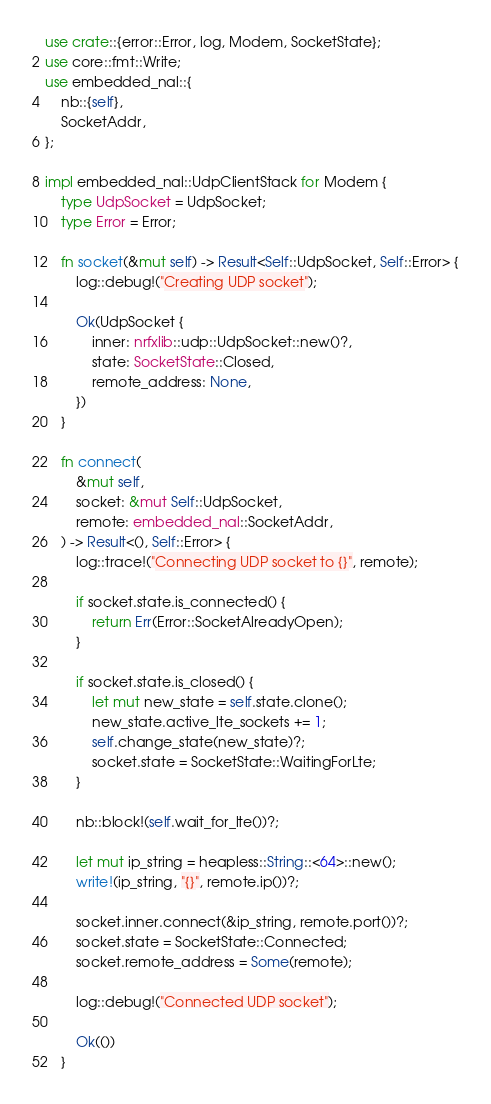Convert code to text. <code><loc_0><loc_0><loc_500><loc_500><_Rust_>use crate::{error::Error, log, Modem, SocketState};
use core::fmt::Write;
use embedded_nal::{
    nb::{self},
    SocketAddr,
};

impl embedded_nal::UdpClientStack for Modem {
    type UdpSocket = UdpSocket;
    type Error = Error;

    fn socket(&mut self) -> Result<Self::UdpSocket, Self::Error> {
        log::debug!("Creating UDP socket");

        Ok(UdpSocket {
            inner: nrfxlib::udp::UdpSocket::new()?,
            state: SocketState::Closed,
            remote_address: None,
        })
    }

    fn connect(
        &mut self,
        socket: &mut Self::UdpSocket,
        remote: embedded_nal::SocketAddr,
    ) -> Result<(), Self::Error> {
        log::trace!("Connecting UDP socket to {}", remote);

        if socket.state.is_connected() {
            return Err(Error::SocketAlreadyOpen);
        }

        if socket.state.is_closed() {
            let mut new_state = self.state.clone();
            new_state.active_lte_sockets += 1;
            self.change_state(new_state)?;
            socket.state = SocketState::WaitingForLte;
        }

        nb::block!(self.wait_for_lte())?;

        let mut ip_string = heapless::String::<64>::new();
        write!(ip_string, "{}", remote.ip())?;

        socket.inner.connect(&ip_string, remote.port())?;
        socket.state = SocketState::Connected;
        socket.remote_address = Some(remote);

        log::debug!("Connected UDP socket");

        Ok(())
    }
</code> 